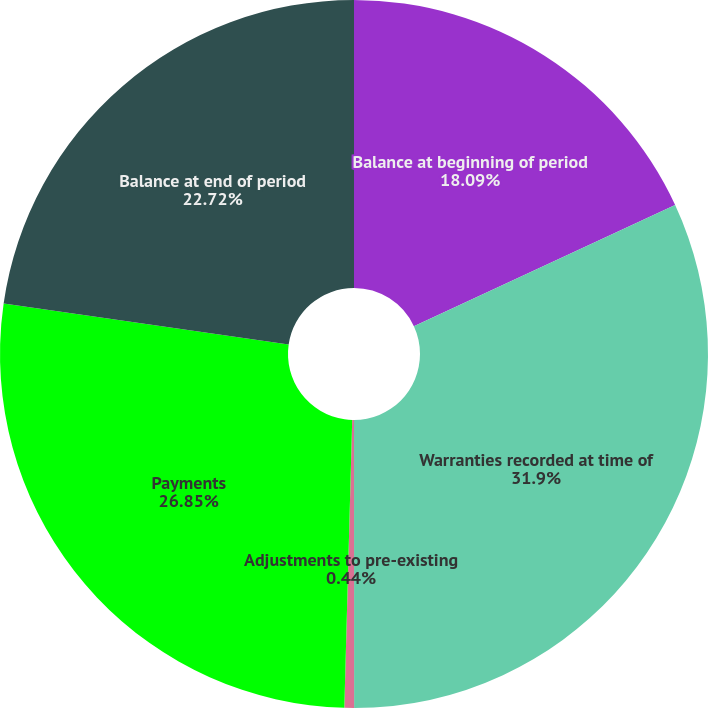Convert chart to OTSL. <chart><loc_0><loc_0><loc_500><loc_500><pie_chart><fcel>Balance at beginning of period<fcel>Warranties recorded at time of<fcel>Adjustments to pre-existing<fcel>Payments<fcel>Balance at end of period<nl><fcel>18.09%<fcel>31.91%<fcel>0.44%<fcel>26.85%<fcel>22.72%<nl></chart> 